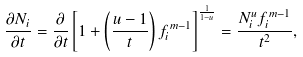<formula> <loc_0><loc_0><loc_500><loc_500>\frac { \partial N _ { i } } { \partial t } = \frac { \partial } { \partial t } \left [ 1 + \left ( \frac { u - 1 } { t } \right ) f _ { i } ^ { \, m - 1 } \right ] ^ { \frac { 1 } { 1 - u } } = \frac { N _ { i } ^ { u } f ^ { \, m - 1 } _ { i } } { t ^ { 2 } } ,</formula> 